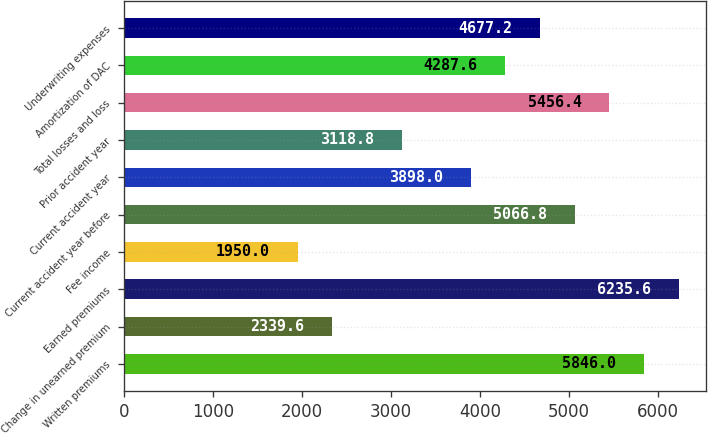Convert chart. <chart><loc_0><loc_0><loc_500><loc_500><bar_chart><fcel>Written premiums<fcel>Change in unearned premium<fcel>Earned premiums<fcel>Fee income<fcel>Current accident year before<fcel>Current accident year<fcel>Prior accident year<fcel>Total losses and loss<fcel>Amortization of DAC<fcel>Underwriting expenses<nl><fcel>5846<fcel>2339.6<fcel>6235.6<fcel>1950<fcel>5066.8<fcel>3898<fcel>3118.8<fcel>5456.4<fcel>4287.6<fcel>4677.2<nl></chart> 